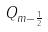Convert formula to latex. <formula><loc_0><loc_0><loc_500><loc_500>Q _ { m - \frac { 1 } { 2 } }</formula> 